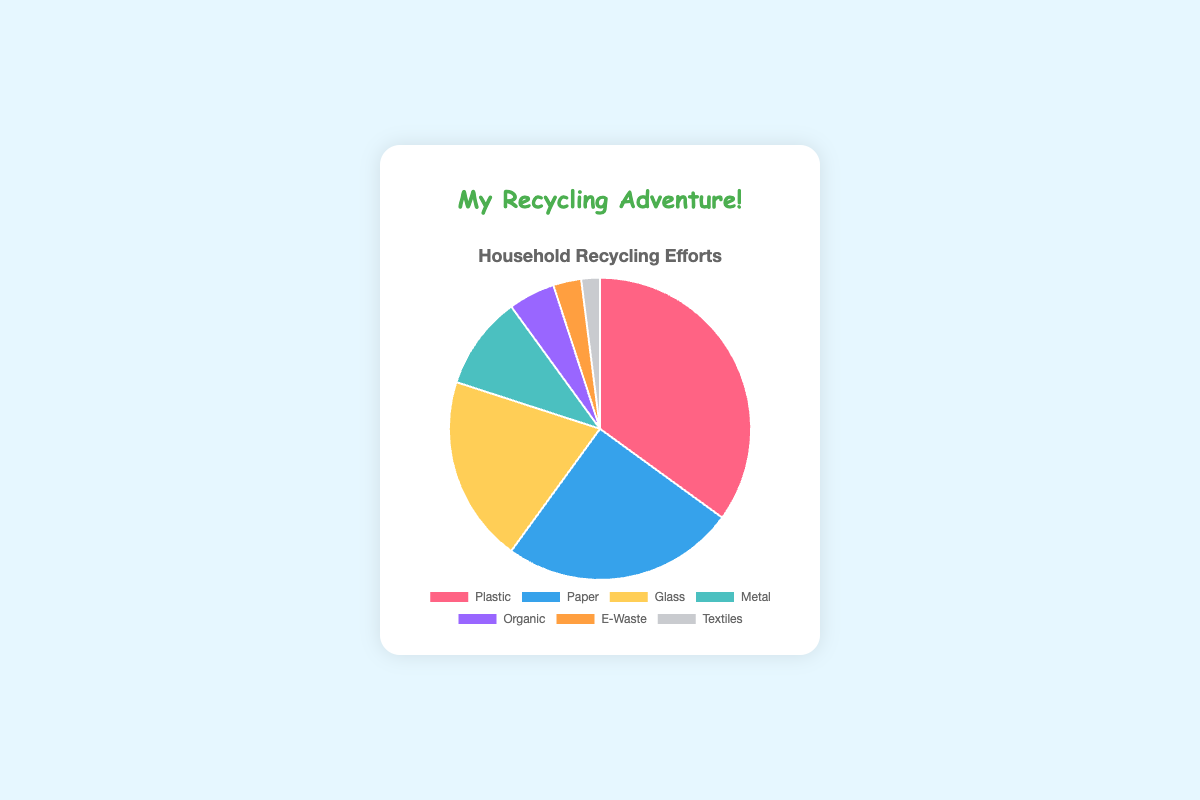What's the most recycled category in households? The pie chart shows the percentage of recycling efforts, and the segment with the largest percentage represents the most recycled category. Plastic has the highest with 35%.
Answer: Plastic Which two categories have the smallest combined recycling efforts? We need to identify the two smallest slices on the pie chart and add their percentages. Textiles have 2% and E-Waste has 3%, so combined, they make up 5%.
Answer: Textiles and E-Waste Does Paper or Glass have a higher recycling effort? By comparing the slices representing Paper and Glass on the pie chart, Paper has 25% while Glass has 20%.
Answer: Paper What's the difference between the least recycled category and the second least recycled category? The least recycled category is Textiles (2%) and the second least recycled is E-Waste (3%). The difference is 3% - 2% = 1%.
Answer: 1% If we grouped Glass, Metal, Organic, E-Waste, and Textiles together, what would their combined recycling effort percentage be? Adding the percentages of these categories gives 20% (Glass) + 10% (Metal) + 5% (Organic) + 3% (E-Waste) + 2% (Textiles) = 40%.
Answer: 40% Which category has a visual segment colored in blue, and what's its recycling percentage? The pie chart shows a blue section, which corresponds to Paper with a percentage of 25%.
Answer: Paper, 25% What fraction of the total recycling efforts involves recycling Plastic? Plastic represents 35% of the recycling efforts. This can be converted to a fraction as 35/100, which simplifies to 7/20.
Answer: 7/20 Are more efforts focused on recycling Metal or Organic materials? By comparing the percentage slices for Metal (10%) and Organic (5%) on the pie chart, Metal has a higher percentage.
Answer: Metal How much more is recycled in the highest category compared to the second highest category? The highest category (Plastic) is 35%, and the second highest (Paper) is 25%. The difference is 35% - 25% = 10%.
Answer: 10% What is the average percentage of recycling efforts for Glass, Metal, and Organic categories? Adding the percentages for these categories (20% + 10% + 5%) gives 35%. Dividing by 3 gives an average of 35% / 3 = 11.67% (rounded to 2 decimal places).
Answer: 11.67% 